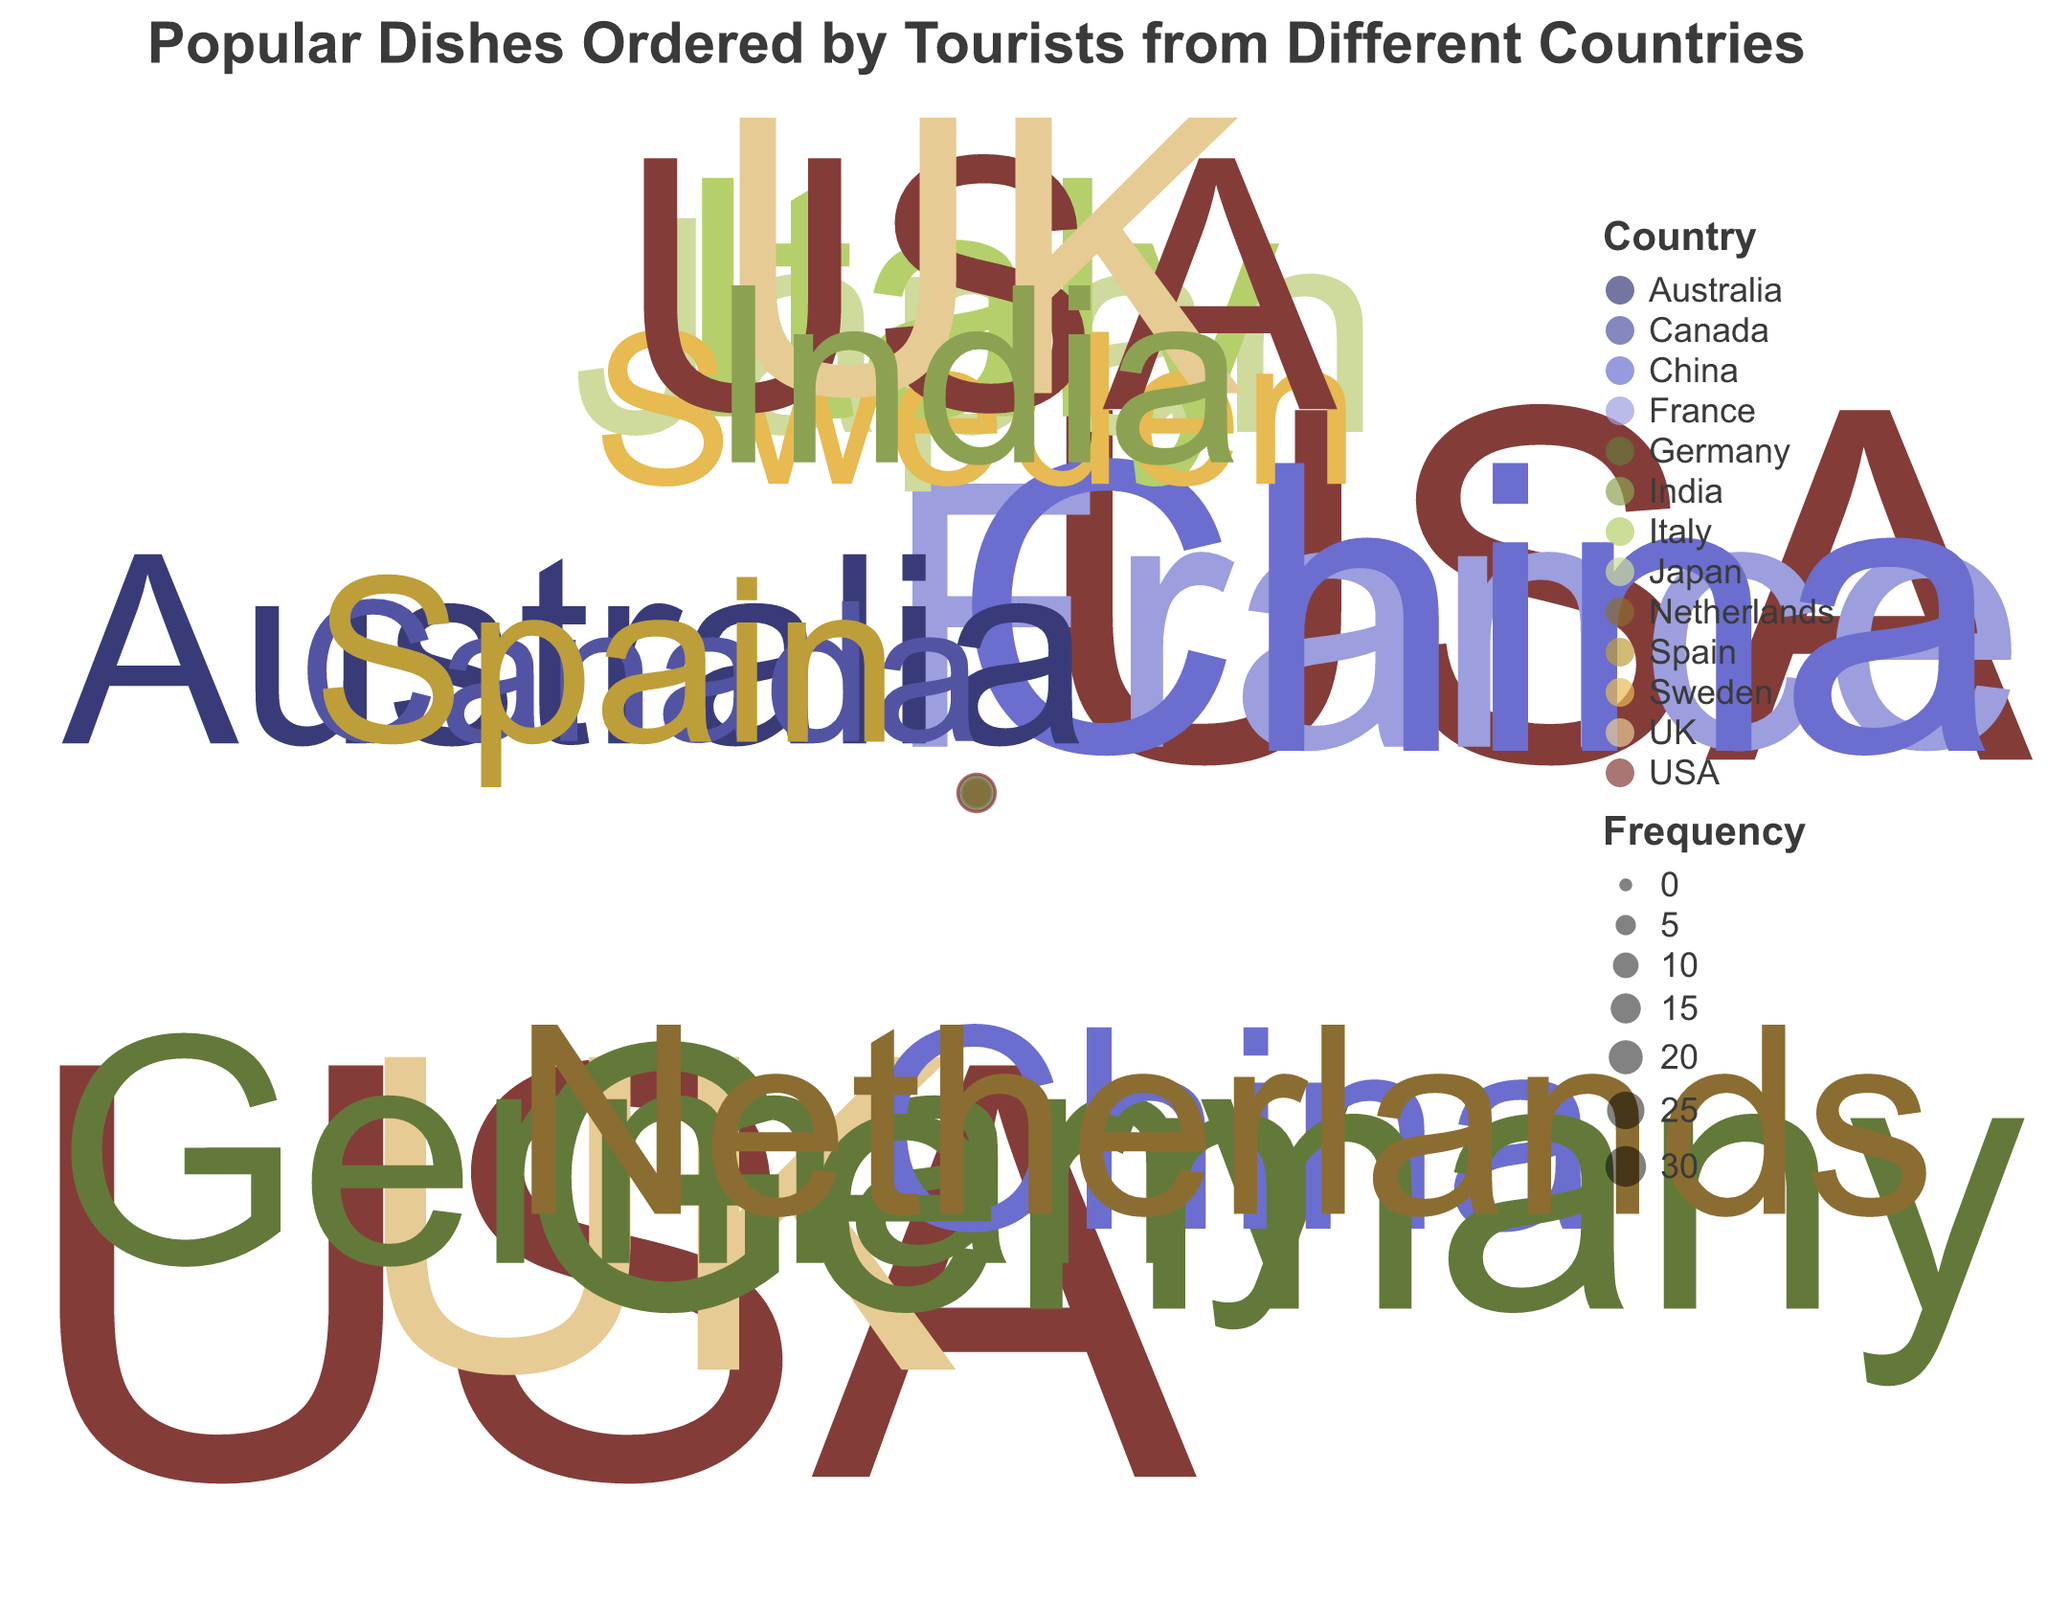How many countries ordered Lamb Biryani? Look at the data points associated with "Lamb Biryani" and count the different countries represented.
Answer: 3 Which dish has the highest frequency from tourists from the USA? Identify all dishes ordered by tourists from "USA" and compare their frequencies to determine which has the highest.
Answer: Lamb Biryani Between Chicken Karahi and Vegetable Biryani, which dish was more popular among tourists from different countries? Compare the combined frequencies of all countries for both "Chicken Karahi" and "Vegetable Biryani". Summing frequencies, "Chicken Karahi" has 25 + 18 + 20 = 63 and "Vegetable Biryani" has 14 + 16 + 9 = 39, making "Chicken Karahi" more popular.
Answer: Chicken Karahi What is the total frequency of dishes ordered by tourists from Germany? Add the frequencies of dishes ordered by tourists from "Germany". That's Lamb Biryani (15) + Chicken Tikka (18) = 33.
Answer: 33 Which country ordered Pakistani Kebab the most? Identify all frequencies for "Pakistani Kebab" and compare them to determine the highest, which is from Australia (12).
Answer: Australia Which dish has the least frequency overall? Compare the frequencies of all dishes and identify the one with the least number of orders. Pakistani Kebab has the lowest individual order frequencies when considering 8 from Canada.
Answer: Pakistani Kebab Is Chicken Tikka more popular in China or Germany? Compare the frequencies of "Chicken Tikka" in "China" (13) and "Germany" (18). Germany has a higher frequency.
Answer: Germany How many different countries ordered Chicken Karahi? Count the unique countries that ordered "Chicken Karahi", which are USA, France, and China (3 countries).
Answer: 3 What is the combined frequency of Chana Masala ordered by tourists from India and UK? Add the frequencies of Chana Masala ordered by tourists from "India" (11) and "UK" (19) which totals to 30.
Answer: 30 Which dish was ordered in Sweden, and what was its frequency? Look for the country "Sweden" and identify the associated dish and its frequency, which is Vegetable Biryani with a frequency of 9.
Answer: Vegetable Biryani, 9 